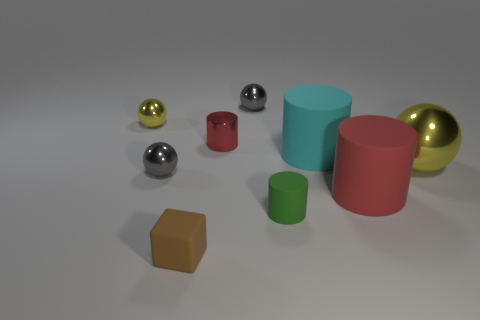Add 1 cyan rubber cylinders. How many objects exist? 10 Subtract all big balls. How many balls are left? 3 Add 4 spheres. How many spheres are left? 8 Add 4 large cyan rubber cylinders. How many large cyan rubber cylinders exist? 5 Subtract all gray balls. How many balls are left? 2 Subtract 1 cyan cylinders. How many objects are left? 8 Subtract all spheres. How many objects are left? 5 Subtract 2 cylinders. How many cylinders are left? 2 Subtract all brown cylinders. Subtract all green blocks. How many cylinders are left? 4 Subtract all cyan cubes. How many cyan cylinders are left? 1 